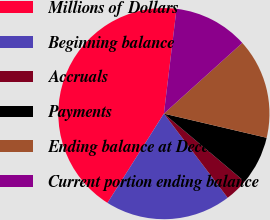Convert chart. <chart><loc_0><loc_0><loc_500><loc_500><pie_chart><fcel>Millions of Dollars<fcel>Beginning balance<fcel>Accruals<fcel>Payments<fcel>Ending balance at December 31<fcel>Current portion ending balance<nl><fcel>42.94%<fcel>19.29%<fcel>3.53%<fcel>7.47%<fcel>15.35%<fcel>11.41%<nl></chart> 